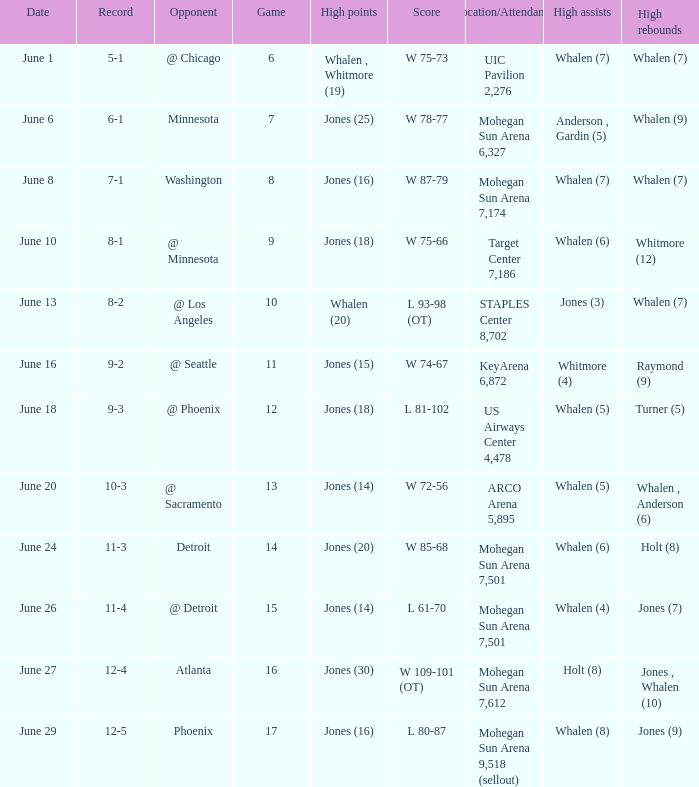Who had the high points on june 8? Jones (16). 